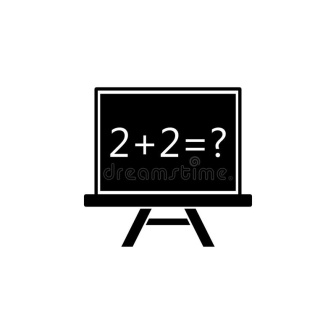Can you describe a creative scenario involving this chalkboard in a magical world? Imagine a world where chalkboards are not just teaching tools but magical artifacts. This particular chalkboard stands in an ancient, mystical classroom hidden deep within an enchanted forest. When someone writes an equation on it, the numbers glow with a golden light. Solving the equation correctly not only proves mathematical prowess but unlocks hidden spells and secrets of the forest. The chalkboard is guarded by wise, ancient beings who guide young apprentices in mastering both arithmetic and magic. In this world, the equation '2 + 2 = ?' might be the first step in unlocking a powerful enchantment that could change the course of history. 